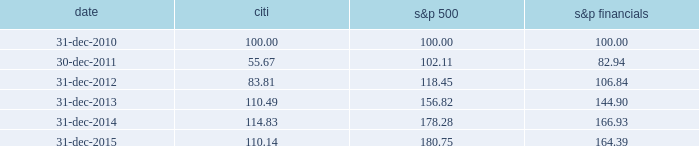Performance graph comparison of five-year cumulative total return the following graph and table compare the cumulative total return on citi 2019s common stock , which is listed on the nyse under the ticker symbol 201cc 201d and held by 81805 common stockholders of record as of january 31 , 2016 , with the cumulative total return of the s&p 500 index and the s&p financial index over the five-year period through december 31 , 2015 .
The graph and table assume that $ 100 was invested on december 31 , 2010 in citi 2019s common stock , the s&p 500 index and the s&p financial index , and that all dividends were reinvested .
Comparison of five-year cumulative total return for the years ended date citi s&p 500 financials .

What was the difference in percentage cumulative total return of citi common stock compared to the s&p financials for the five years ended 31-dec-2015? 
Computations: (((110.14 - 100) / 100) - ((164.39 - 100) / 100))
Answer: -0.5425. 